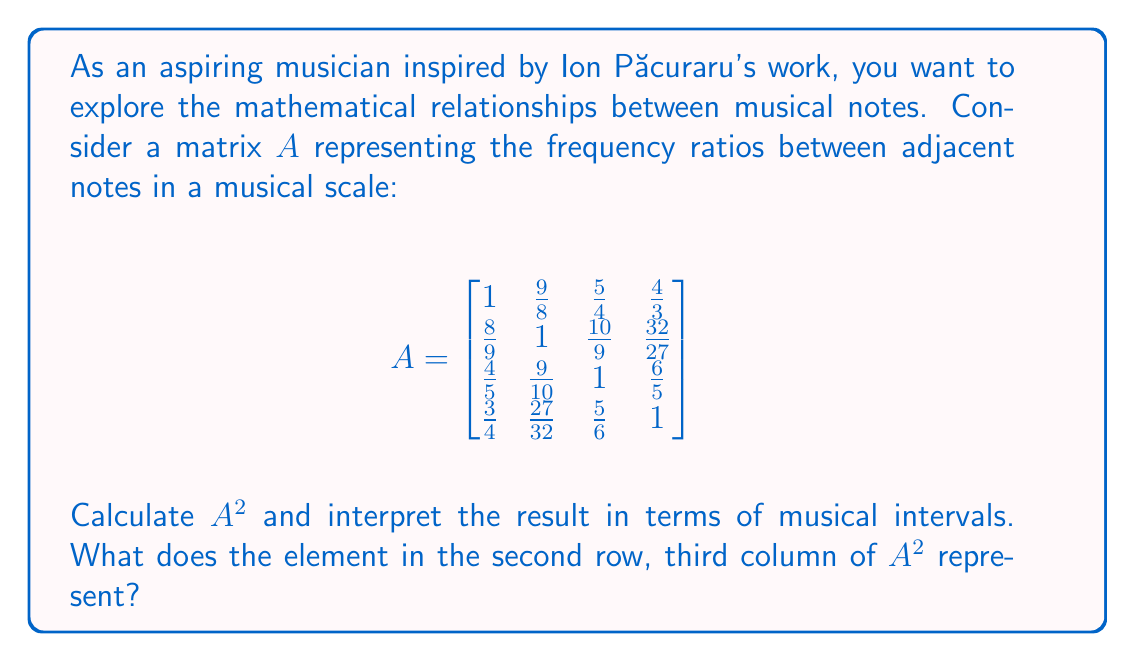Give your solution to this math problem. To solve this problem, we need to calculate $A^2$ by multiplying matrix $A$ by itself. This operation will give us the frequency ratios between notes that are two steps apart in the scale.

Let's calculate $A^2$:

$$A^2 = A \times A = \begin{bmatrix}
1 & \frac{9}{8} & \frac{5}{4} & \frac{4}{3} \\
\frac{8}{9} & 1 & \frac{10}{9} & \frac{32}{27} \\
\frac{4}{5} & \frac{9}{10} & 1 & \frac{6}{5} \\
\frac{3}{4} & \frac{27}{32} & \frac{5}{6} & 1
\end{bmatrix} \times \begin{bmatrix}
1 & \frac{9}{8} & \frac{5}{4} & \frac{4}{3} \\
\frac{8}{9} & 1 & \frac{10}{9} & \frac{32}{27} \\
\frac{4}{5} & \frac{9}{10} & 1 & \frac{6}{5} \\
\frac{3}{4} & \frac{27}{32} & \frac{5}{6} & 1
\end{bmatrix}$$

Performing the matrix multiplication, we get:

$$A^2 = \begin{bmatrix}
1 & \frac{81}{64} & \frac{25}{16} & \frac{16}{9} \\
\frac{64}{81} & 1 & \frac{25}{18} & \frac{128}{81} \\
\frac{16}{25} & \frac{18}{25} & 1 & \frac{36}{25} \\
\frac{9}{16} & \frac{81}{128} & \frac{25}{36} & 1
\end{bmatrix}$$

The element in the second row, third column of $A^2$ is $\frac{25}{18}$.

Interpretation:
In music theory, frequency ratios represent intervals between notes. The original matrix $A$ represents intervals between adjacent notes, while $A^2$ represents intervals between notes that are two steps apart in the scale.

The element $\frac{25}{18}$ in the second row, third column of $A^2$ represents the frequency ratio between the second and fourth notes of the original scale. This interval is known as a "major third" in Western music theory.

In the context of Ion Păcuraru's work, which often involves Romanian folk music, this mathematical approach to understanding musical intervals can be particularly interesting. It allows for a deeper analysis of the musical scales and harmonies used in traditional Romanian music, as well as providing a foundation for creating new musical compositions inspired by these mathematical relationships.
Answer: The element in the second row, third column of $A^2$ is $\frac{25}{18}$, which represents the frequency ratio of a major third interval between the second and fourth notes of the original scale. 